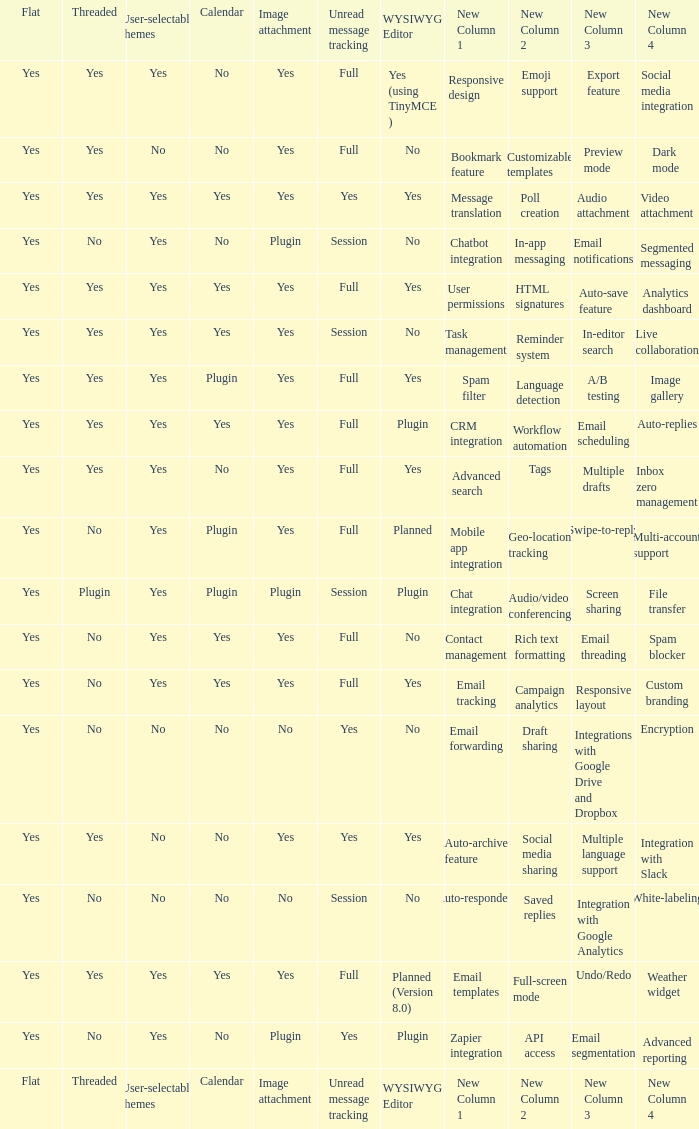Which WYSIWYG Editor has an Image attachment of yes, and a Calendar of plugin? Yes, Planned. 